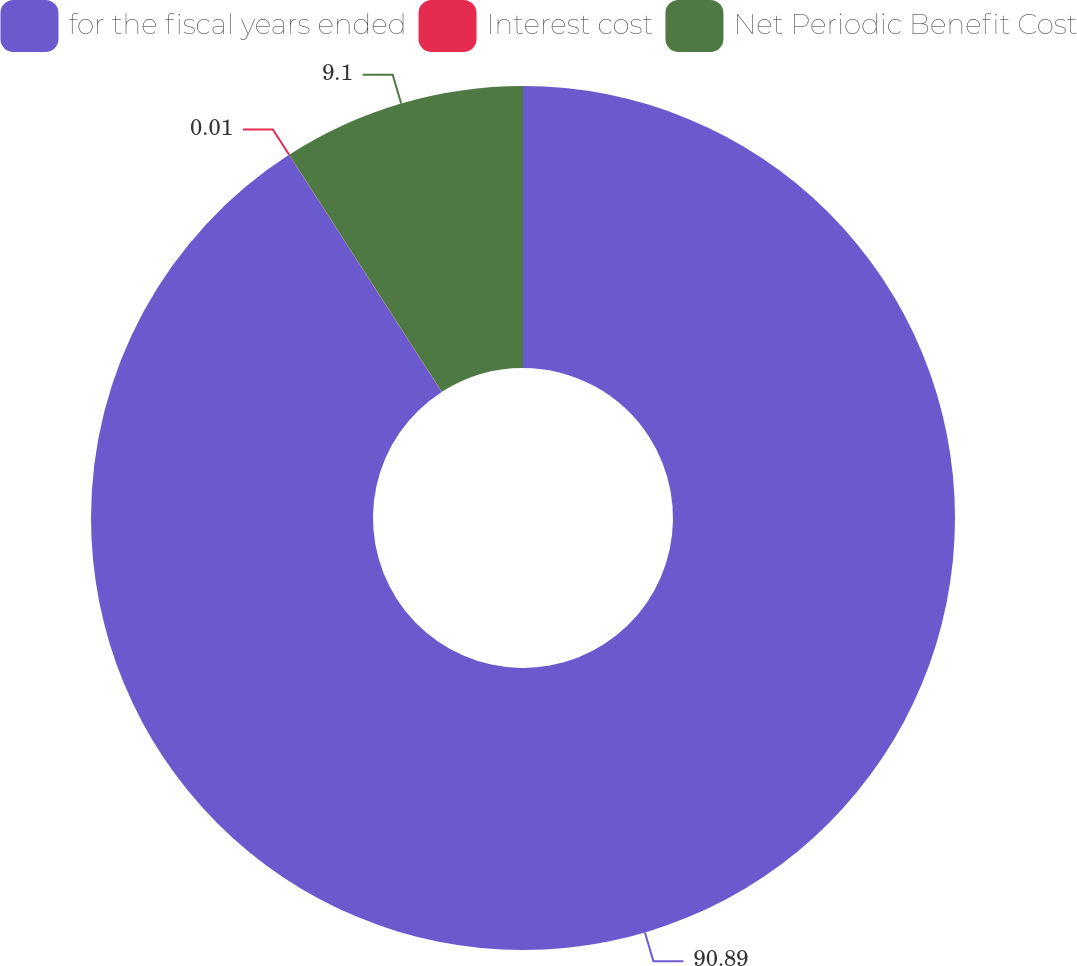Convert chart to OTSL. <chart><loc_0><loc_0><loc_500><loc_500><pie_chart><fcel>for the fiscal years ended<fcel>Interest cost<fcel>Net Periodic Benefit Cost<nl><fcel>90.89%<fcel>0.01%<fcel>9.1%<nl></chart> 